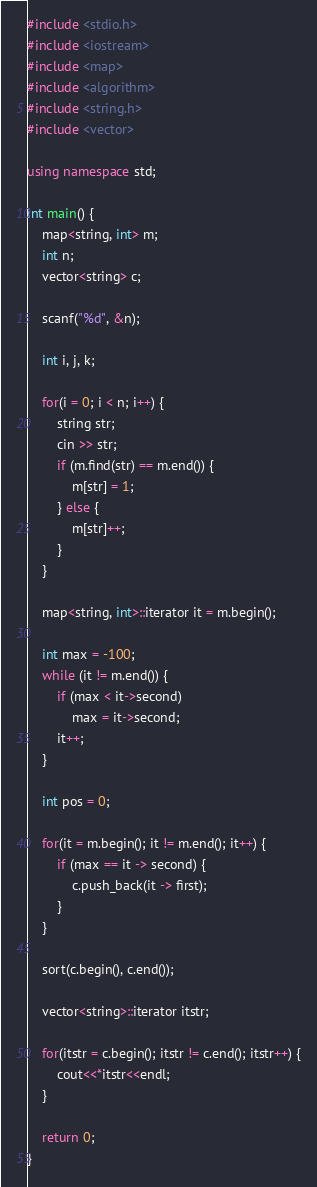<code> <loc_0><loc_0><loc_500><loc_500><_C++_>#include <stdio.h>
#include <iostream>
#include <map>
#include <algorithm>
#include <string.h>
#include <vector>

using namespace std;

int main() {
    map<string, int> m;
    int n;
    vector<string> c;

    scanf("%d", &n);

    int i, j, k;

    for(i = 0; i < n; i++) {
        string str;
        cin >> str;
        if (m.find(str) == m.end()) {
            m[str] = 1;
        } else {
            m[str]++;
        }
    }

    map<string, int>::iterator it = m.begin();

    int max = -100;
    while (it != m.end()) {
        if (max < it->second)
            max = it->second;
        it++;
    }

    int pos = 0;

    for(it = m.begin(); it != m.end(); it++) {
        if (max == it -> second) {
            c.push_back(it -> first);
        }
    }

    sort(c.begin(), c.end());

    vector<string>::iterator itstr;

    for(itstr = c.begin(); itstr != c.end(); itstr++) {
        cout<<*itstr<<endl;
    }

    return 0;
}

</code> 